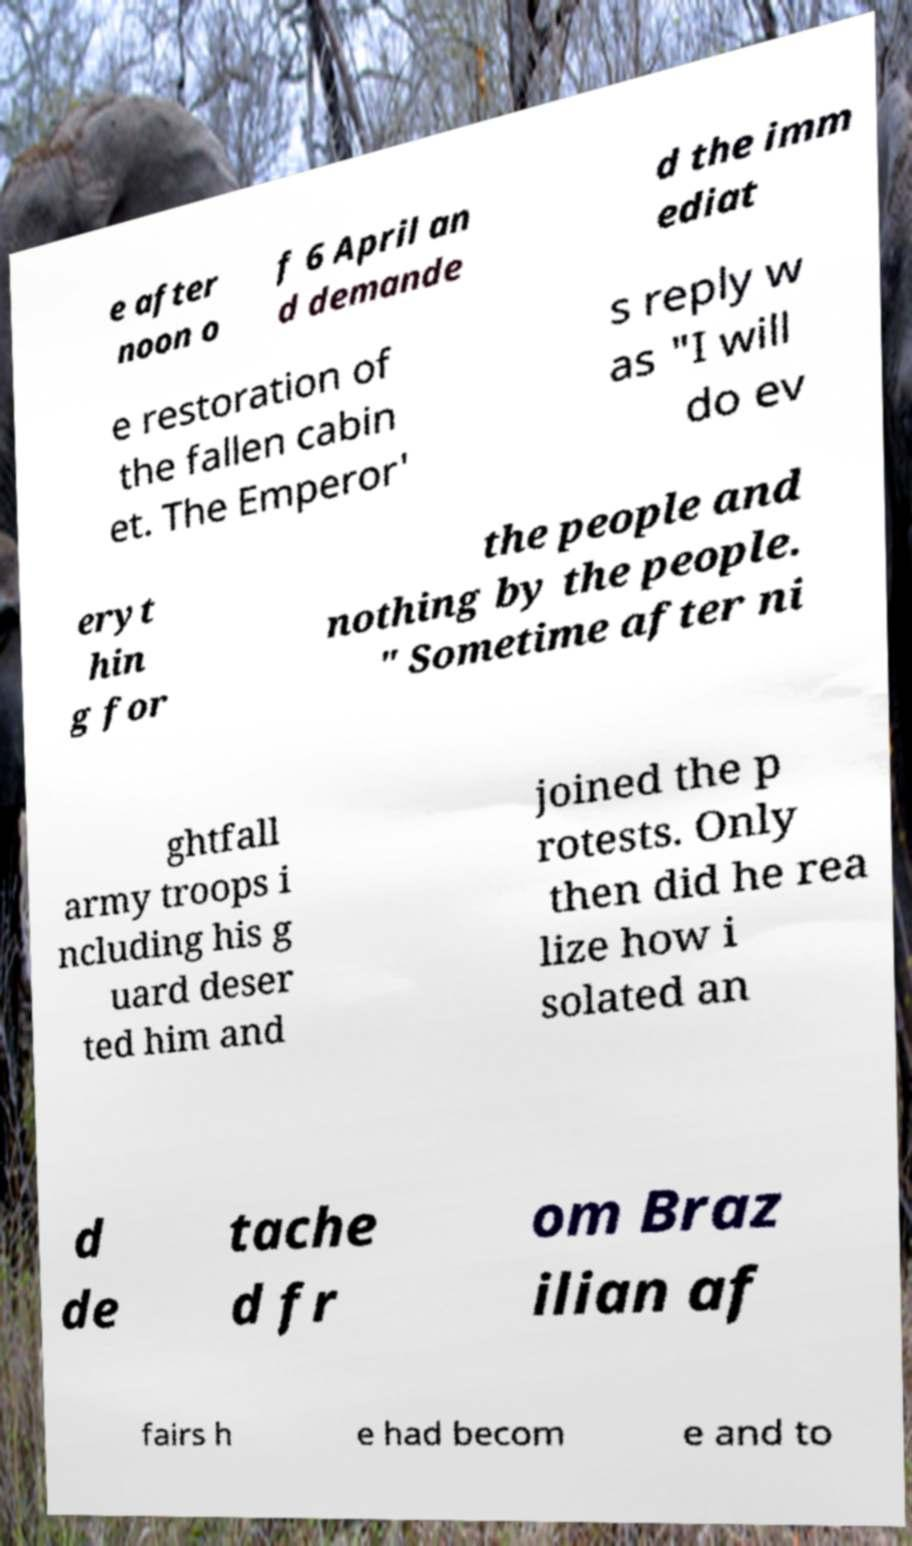Can you read and provide the text displayed in the image?This photo seems to have some interesting text. Can you extract and type it out for me? e after noon o f 6 April an d demande d the imm ediat e restoration of the fallen cabin et. The Emperor' s reply w as "I will do ev eryt hin g for the people and nothing by the people. " Sometime after ni ghtfall army troops i ncluding his g uard deser ted him and joined the p rotests. Only then did he rea lize how i solated an d de tache d fr om Braz ilian af fairs h e had becom e and to 